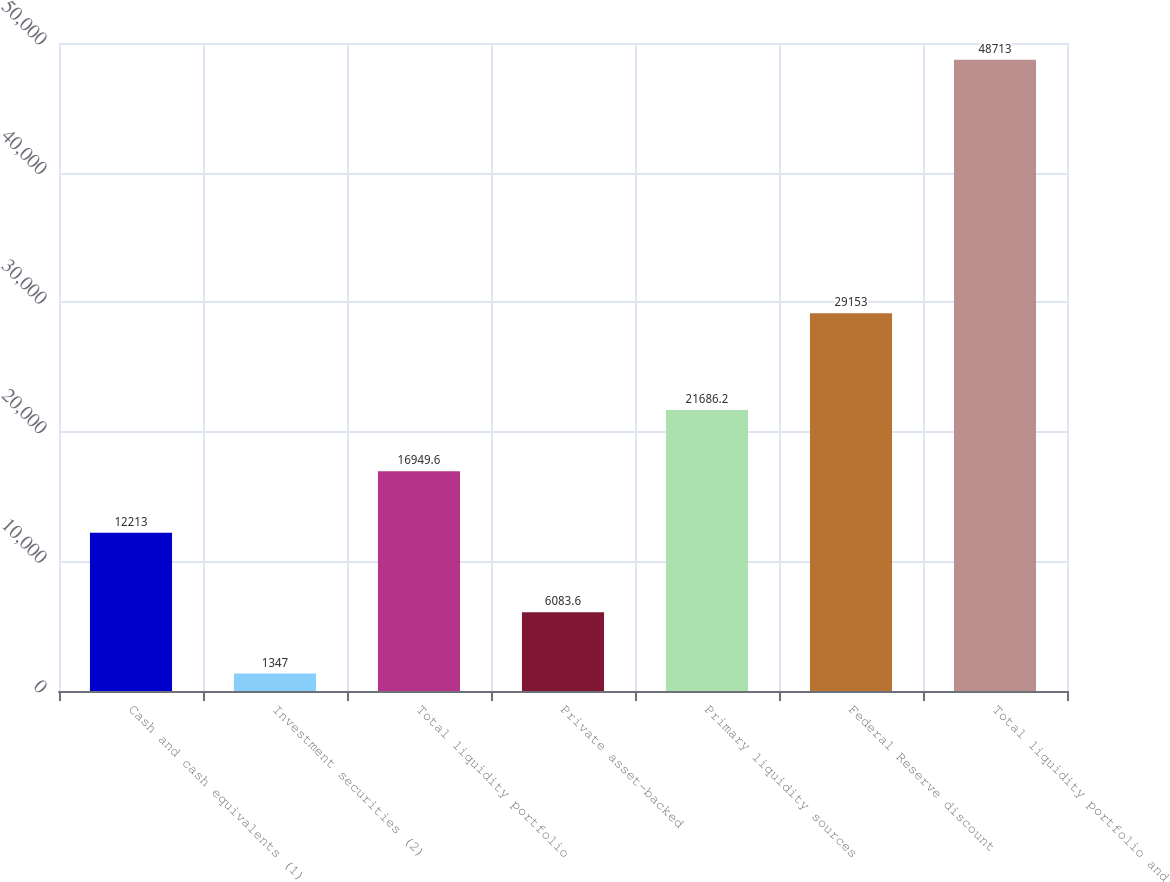Convert chart to OTSL. <chart><loc_0><loc_0><loc_500><loc_500><bar_chart><fcel>Cash and cash equivalents (1)<fcel>Investment securities (2)<fcel>Total liquidity portfolio<fcel>Private asset-backed<fcel>Primary liquidity sources<fcel>Federal Reserve discount<fcel>Total liquidity portfolio and<nl><fcel>12213<fcel>1347<fcel>16949.6<fcel>6083.6<fcel>21686.2<fcel>29153<fcel>48713<nl></chart> 